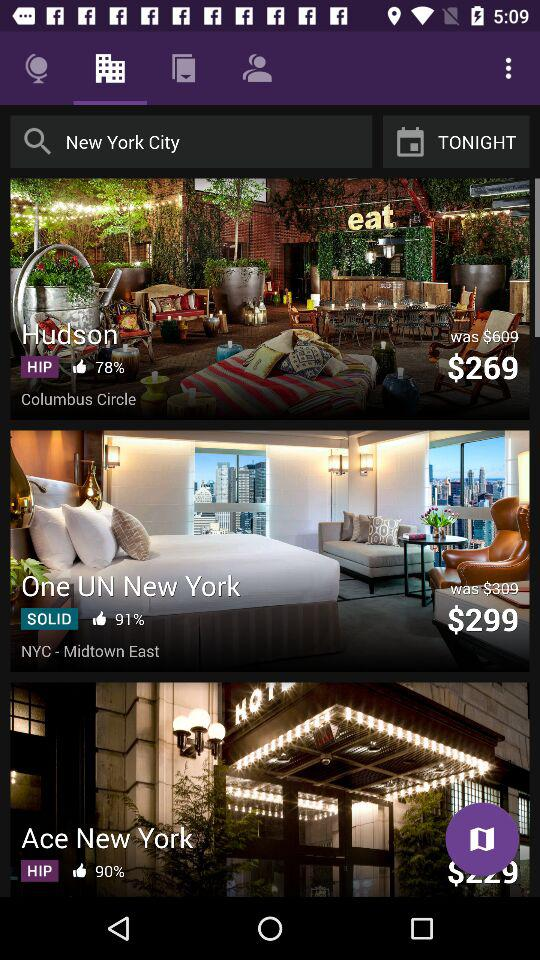How many guests are staying in the hotel?
When the provided information is insufficient, respond with <no answer>. <no answer> 